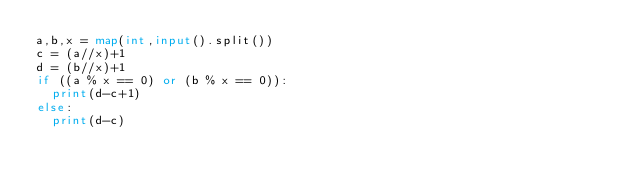Convert code to text. <code><loc_0><loc_0><loc_500><loc_500><_Python_>a,b,x = map(int,input().split())
c = (a//x)+1
d = (b//x)+1
if ((a % x == 0) or (b % x == 0)):
  print(d-c+1)
else:
  print(d-c)</code> 